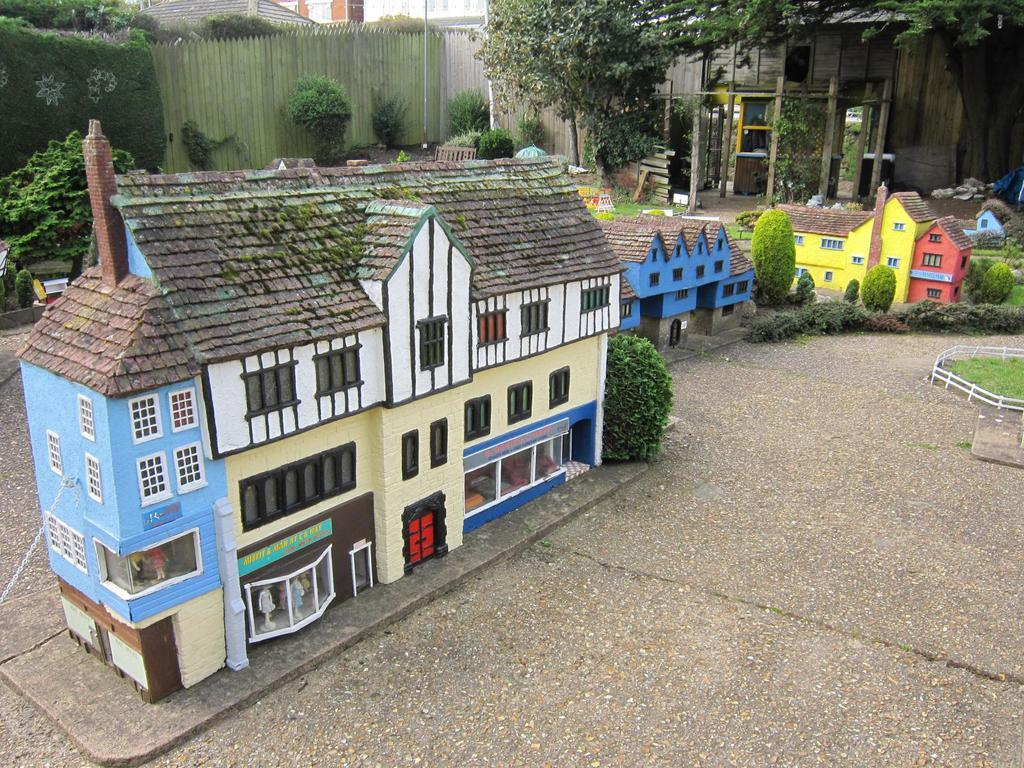What type of miniature arts are present in the image? There are miniature arts of buildings in the image. Are there any other elements between the buildings? Yes, there are tiny plants between the buildings. What can be seen in the background of the image? There are trees and plants in the background of the image. How many baseballs can be seen in the image? There are no baseballs present in the image. What type of boot is visible in the image? There is no boot present in the image. 